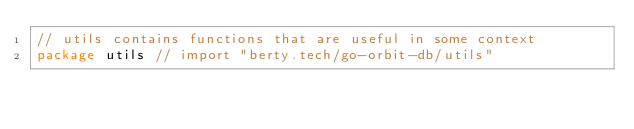<code> <loc_0><loc_0><loc_500><loc_500><_Go_>// utils contains functions that are useful in some context
package utils // import "berty.tech/go-orbit-db/utils"
</code> 